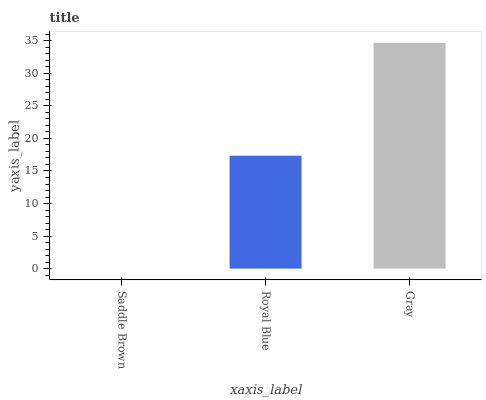Is Saddle Brown the minimum?
Answer yes or no. Yes. Is Gray the maximum?
Answer yes or no. Yes. Is Royal Blue the minimum?
Answer yes or no. No. Is Royal Blue the maximum?
Answer yes or no. No. Is Royal Blue greater than Saddle Brown?
Answer yes or no. Yes. Is Saddle Brown less than Royal Blue?
Answer yes or no. Yes. Is Saddle Brown greater than Royal Blue?
Answer yes or no. No. Is Royal Blue less than Saddle Brown?
Answer yes or no. No. Is Royal Blue the high median?
Answer yes or no. Yes. Is Royal Blue the low median?
Answer yes or no. Yes. Is Saddle Brown the high median?
Answer yes or no. No. Is Gray the low median?
Answer yes or no. No. 